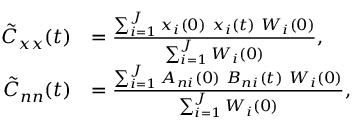Convert formula to latex. <formula><loc_0><loc_0><loc_500><loc_500>\begin{array} { r l } { \tilde { C } _ { x x } ( t ) } & { = \frac { \sum _ { i = 1 } ^ { J } x _ { i } ( 0 ) \ x _ { i } ( t ) \ W _ { i } ( 0 ) } { \sum _ { i = 1 } ^ { J } W _ { i } ( 0 ) } , } \\ { \tilde { C } _ { n n } ( t ) } & { = \frac { \sum _ { i = 1 } ^ { J } A _ { n i } ( 0 ) \ B _ { n i } ( t ) \ W _ { i } ( 0 ) } { \sum _ { i = 1 } ^ { J } W _ { i } ( 0 ) } , } \end{array}</formula> 